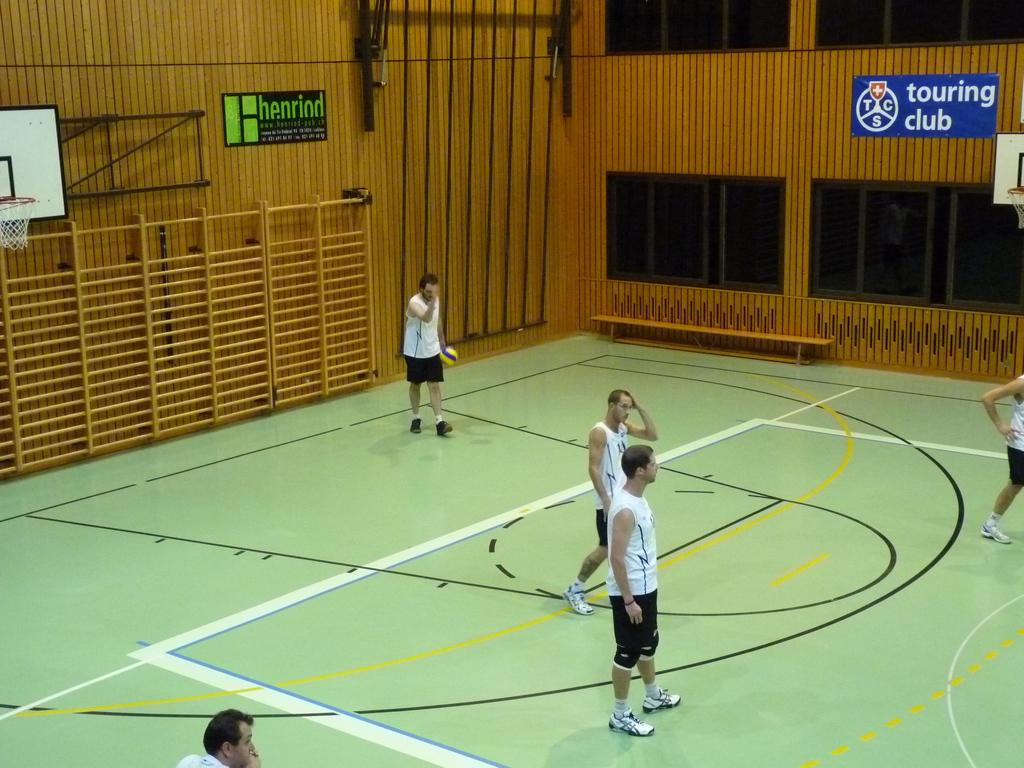<image>
Write a terse but informative summary of the picture. Men are playing basketball in a court with a green floor and a blue sign that says touring club. 